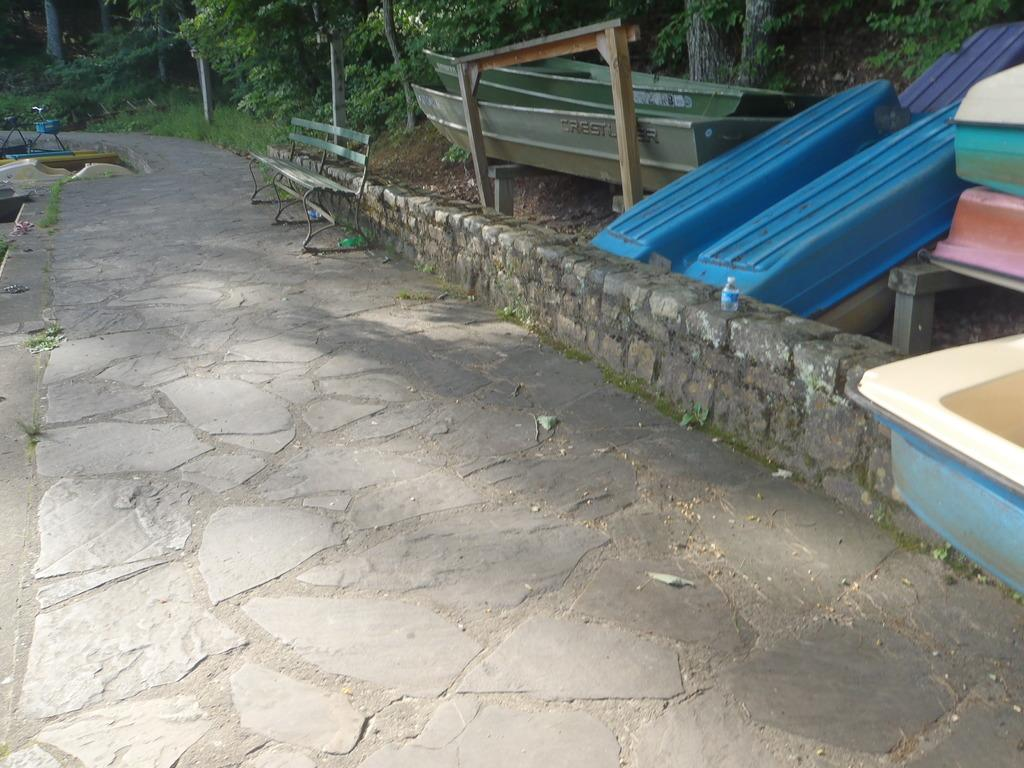What type of vehicles can be seen in the image? There are boats in the image. What type of seating is available in the image? There are benches in the image. What type of vegetation can be seen in the background of the image? There are trees in the background of the image. What type of ground surface is visible in the background of the image? There is grass visible in the background of the image. Where is the nut located in the image? There is no nut present in the image. Can you describe the sink in the image? There is no sink present in the image. 